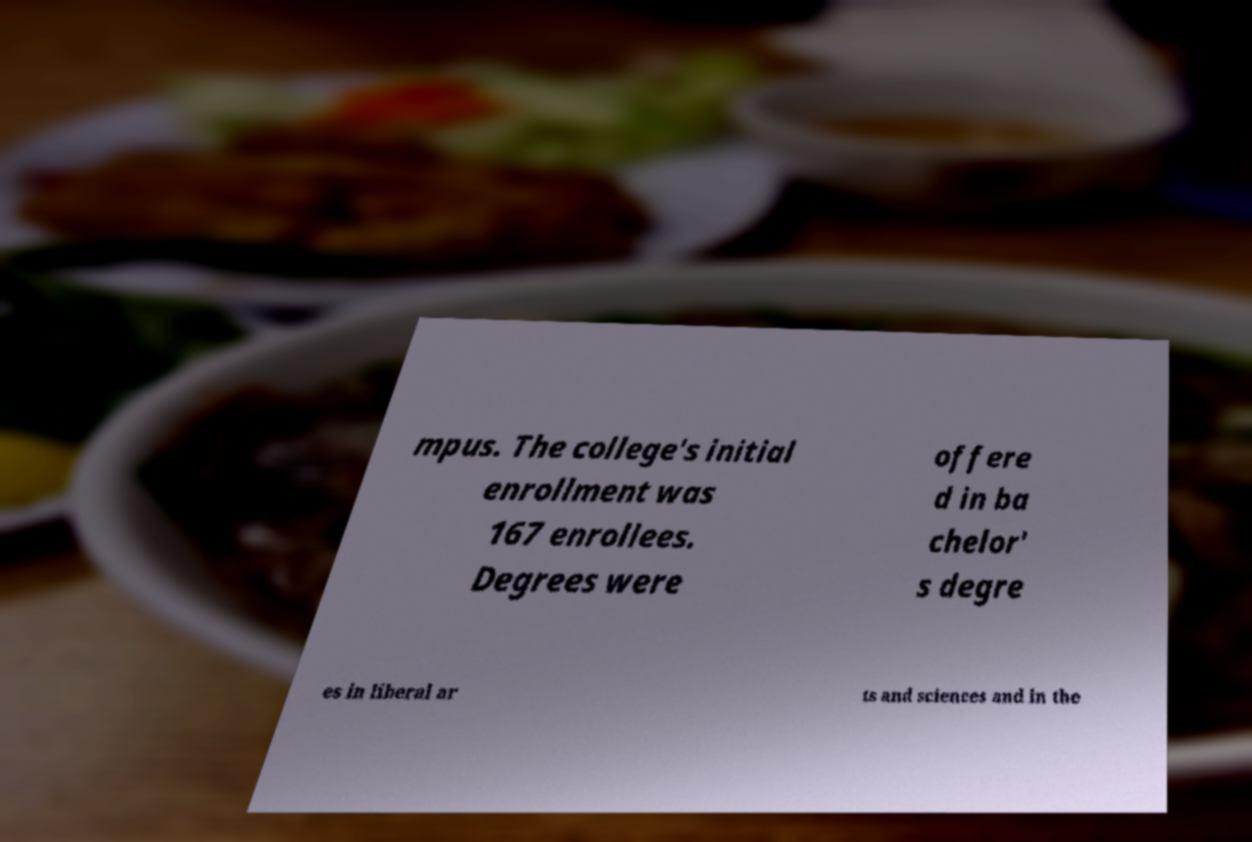Please identify and transcribe the text found in this image. mpus. The college's initial enrollment was 167 enrollees. Degrees were offere d in ba chelor' s degre es in liberal ar ts and sciences and in the 